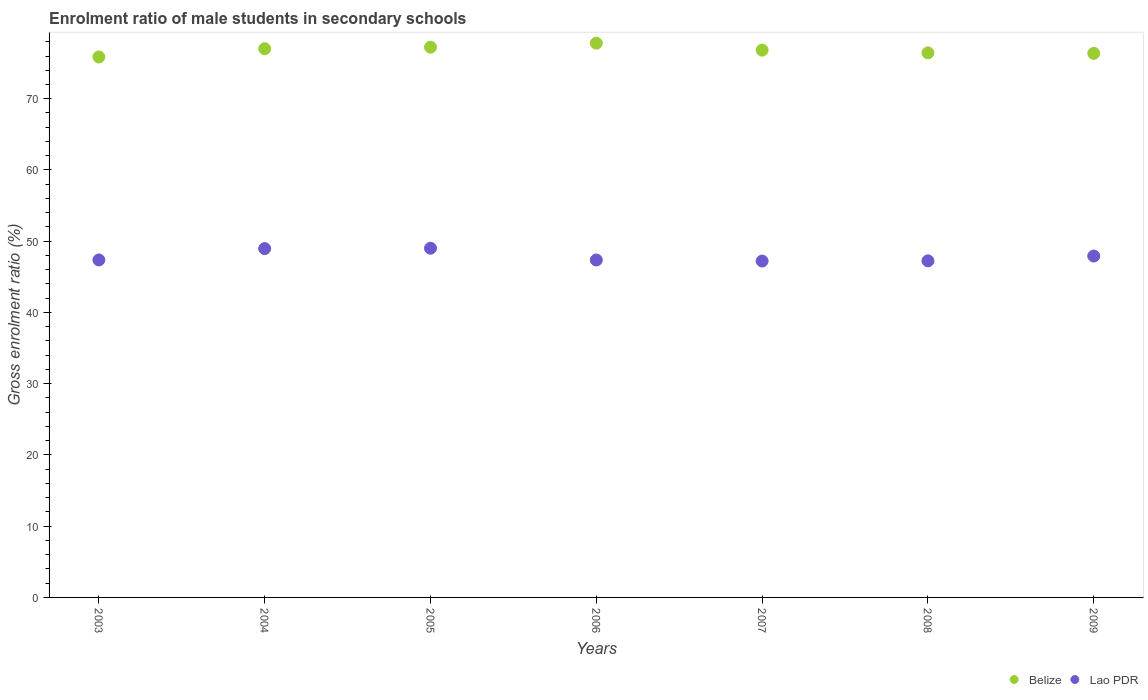Is the number of dotlines equal to the number of legend labels?
Keep it short and to the point. Yes. What is the enrolment ratio of male students in secondary schools in Belize in 2006?
Keep it short and to the point. 77.8. Across all years, what is the maximum enrolment ratio of male students in secondary schools in Lao PDR?
Make the answer very short. 49.02. Across all years, what is the minimum enrolment ratio of male students in secondary schools in Belize?
Provide a succinct answer. 75.86. What is the total enrolment ratio of male students in secondary schools in Belize in the graph?
Provide a short and direct response. 537.56. What is the difference between the enrolment ratio of male students in secondary schools in Belize in 2003 and that in 2004?
Keep it short and to the point. -1.16. What is the difference between the enrolment ratio of male students in secondary schools in Lao PDR in 2005 and the enrolment ratio of male students in secondary schools in Belize in 2007?
Offer a terse response. -27.81. What is the average enrolment ratio of male students in secondary schools in Belize per year?
Offer a terse response. 76.79. In the year 2004, what is the difference between the enrolment ratio of male students in secondary schools in Belize and enrolment ratio of male students in secondary schools in Lao PDR?
Offer a terse response. 28.05. What is the ratio of the enrolment ratio of male students in secondary schools in Lao PDR in 2004 to that in 2008?
Offer a very short reply. 1.04. Is the enrolment ratio of male students in secondary schools in Lao PDR in 2005 less than that in 2008?
Provide a short and direct response. No. What is the difference between the highest and the second highest enrolment ratio of male students in secondary schools in Lao PDR?
Keep it short and to the point. 0.05. What is the difference between the highest and the lowest enrolment ratio of male students in secondary schools in Lao PDR?
Offer a very short reply. 1.8. Is the enrolment ratio of male students in secondary schools in Belize strictly less than the enrolment ratio of male students in secondary schools in Lao PDR over the years?
Your response must be concise. No. Does the graph contain any zero values?
Your response must be concise. No. Does the graph contain grids?
Provide a succinct answer. No. How many legend labels are there?
Keep it short and to the point. 2. What is the title of the graph?
Your answer should be compact. Enrolment ratio of male students in secondary schools. Does "United Kingdom" appear as one of the legend labels in the graph?
Provide a succinct answer. No. What is the Gross enrolment ratio (%) in Belize in 2003?
Provide a short and direct response. 75.86. What is the Gross enrolment ratio (%) of Lao PDR in 2003?
Offer a terse response. 47.37. What is the Gross enrolment ratio (%) in Belize in 2004?
Provide a succinct answer. 77.02. What is the Gross enrolment ratio (%) of Lao PDR in 2004?
Make the answer very short. 48.97. What is the Gross enrolment ratio (%) of Belize in 2005?
Provide a succinct answer. 77.24. What is the Gross enrolment ratio (%) of Lao PDR in 2005?
Make the answer very short. 49.02. What is the Gross enrolment ratio (%) in Belize in 2006?
Your response must be concise. 77.8. What is the Gross enrolment ratio (%) in Lao PDR in 2006?
Keep it short and to the point. 47.37. What is the Gross enrolment ratio (%) of Belize in 2007?
Your answer should be very brief. 76.82. What is the Gross enrolment ratio (%) of Lao PDR in 2007?
Your response must be concise. 47.22. What is the Gross enrolment ratio (%) in Belize in 2008?
Offer a terse response. 76.44. What is the Gross enrolment ratio (%) of Lao PDR in 2008?
Your response must be concise. 47.24. What is the Gross enrolment ratio (%) of Belize in 2009?
Your answer should be very brief. 76.37. What is the Gross enrolment ratio (%) of Lao PDR in 2009?
Make the answer very short. 47.92. Across all years, what is the maximum Gross enrolment ratio (%) of Belize?
Your answer should be compact. 77.8. Across all years, what is the maximum Gross enrolment ratio (%) in Lao PDR?
Ensure brevity in your answer.  49.02. Across all years, what is the minimum Gross enrolment ratio (%) of Belize?
Keep it short and to the point. 75.86. Across all years, what is the minimum Gross enrolment ratio (%) of Lao PDR?
Provide a short and direct response. 47.22. What is the total Gross enrolment ratio (%) in Belize in the graph?
Provide a succinct answer. 537.56. What is the total Gross enrolment ratio (%) of Lao PDR in the graph?
Ensure brevity in your answer.  335.11. What is the difference between the Gross enrolment ratio (%) in Belize in 2003 and that in 2004?
Your answer should be very brief. -1.16. What is the difference between the Gross enrolment ratio (%) of Lao PDR in 2003 and that in 2004?
Your response must be concise. -1.59. What is the difference between the Gross enrolment ratio (%) in Belize in 2003 and that in 2005?
Provide a short and direct response. -1.38. What is the difference between the Gross enrolment ratio (%) in Lao PDR in 2003 and that in 2005?
Make the answer very short. -1.65. What is the difference between the Gross enrolment ratio (%) of Belize in 2003 and that in 2006?
Give a very brief answer. -1.94. What is the difference between the Gross enrolment ratio (%) of Lao PDR in 2003 and that in 2006?
Your answer should be very brief. 0.01. What is the difference between the Gross enrolment ratio (%) of Belize in 2003 and that in 2007?
Offer a terse response. -0.96. What is the difference between the Gross enrolment ratio (%) in Lao PDR in 2003 and that in 2007?
Offer a very short reply. 0.15. What is the difference between the Gross enrolment ratio (%) in Belize in 2003 and that in 2008?
Offer a terse response. -0.58. What is the difference between the Gross enrolment ratio (%) in Lao PDR in 2003 and that in 2008?
Provide a short and direct response. 0.13. What is the difference between the Gross enrolment ratio (%) of Belize in 2003 and that in 2009?
Ensure brevity in your answer.  -0.5. What is the difference between the Gross enrolment ratio (%) in Lao PDR in 2003 and that in 2009?
Offer a terse response. -0.55. What is the difference between the Gross enrolment ratio (%) in Belize in 2004 and that in 2005?
Provide a short and direct response. -0.22. What is the difference between the Gross enrolment ratio (%) of Lao PDR in 2004 and that in 2005?
Offer a terse response. -0.05. What is the difference between the Gross enrolment ratio (%) in Belize in 2004 and that in 2006?
Your answer should be compact. -0.78. What is the difference between the Gross enrolment ratio (%) in Lao PDR in 2004 and that in 2006?
Your response must be concise. 1.6. What is the difference between the Gross enrolment ratio (%) in Belize in 2004 and that in 2007?
Offer a terse response. 0.2. What is the difference between the Gross enrolment ratio (%) of Lao PDR in 2004 and that in 2007?
Ensure brevity in your answer.  1.75. What is the difference between the Gross enrolment ratio (%) of Belize in 2004 and that in 2008?
Offer a terse response. 0.58. What is the difference between the Gross enrolment ratio (%) of Lao PDR in 2004 and that in 2008?
Make the answer very short. 1.72. What is the difference between the Gross enrolment ratio (%) in Belize in 2004 and that in 2009?
Provide a short and direct response. 0.65. What is the difference between the Gross enrolment ratio (%) of Lao PDR in 2004 and that in 2009?
Provide a short and direct response. 1.05. What is the difference between the Gross enrolment ratio (%) of Belize in 2005 and that in 2006?
Your answer should be very brief. -0.56. What is the difference between the Gross enrolment ratio (%) in Lao PDR in 2005 and that in 2006?
Make the answer very short. 1.65. What is the difference between the Gross enrolment ratio (%) of Belize in 2005 and that in 2007?
Your answer should be very brief. 0.42. What is the difference between the Gross enrolment ratio (%) of Lao PDR in 2005 and that in 2007?
Offer a terse response. 1.8. What is the difference between the Gross enrolment ratio (%) in Belize in 2005 and that in 2008?
Give a very brief answer. 0.8. What is the difference between the Gross enrolment ratio (%) in Lao PDR in 2005 and that in 2008?
Your answer should be compact. 1.77. What is the difference between the Gross enrolment ratio (%) of Belize in 2005 and that in 2009?
Provide a succinct answer. 0.87. What is the difference between the Gross enrolment ratio (%) in Lao PDR in 2005 and that in 2009?
Offer a very short reply. 1.1. What is the difference between the Gross enrolment ratio (%) in Belize in 2006 and that in 2007?
Your answer should be compact. 0.98. What is the difference between the Gross enrolment ratio (%) in Lao PDR in 2006 and that in 2007?
Keep it short and to the point. 0.15. What is the difference between the Gross enrolment ratio (%) in Belize in 2006 and that in 2008?
Your answer should be very brief. 1.36. What is the difference between the Gross enrolment ratio (%) in Lao PDR in 2006 and that in 2008?
Make the answer very short. 0.12. What is the difference between the Gross enrolment ratio (%) in Belize in 2006 and that in 2009?
Give a very brief answer. 1.44. What is the difference between the Gross enrolment ratio (%) in Lao PDR in 2006 and that in 2009?
Give a very brief answer. -0.55. What is the difference between the Gross enrolment ratio (%) of Belize in 2007 and that in 2008?
Ensure brevity in your answer.  0.38. What is the difference between the Gross enrolment ratio (%) in Lao PDR in 2007 and that in 2008?
Offer a very short reply. -0.03. What is the difference between the Gross enrolment ratio (%) in Belize in 2007 and that in 2009?
Your response must be concise. 0.46. What is the difference between the Gross enrolment ratio (%) of Lao PDR in 2007 and that in 2009?
Ensure brevity in your answer.  -0.7. What is the difference between the Gross enrolment ratio (%) in Belize in 2008 and that in 2009?
Keep it short and to the point. 0.07. What is the difference between the Gross enrolment ratio (%) in Lao PDR in 2008 and that in 2009?
Your answer should be compact. -0.67. What is the difference between the Gross enrolment ratio (%) of Belize in 2003 and the Gross enrolment ratio (%) of Lao PDR in 2004?
Provide a short and direct response. 26.9. What is the difference between the Gross enrolment ratio (%) in Belize in 2003 and the Gross enrolment ratio (%) in Lao PDR in 2005?
Make the answer very short. 26.85. What is the difference between the Gross enrolment ratio (%) in Belize in 2003 and the Gross enrolment ratio (%) in Lao PDR in 2006?
Offer a terse response. 28.5. What is the difference between the Gross enrolment ratio (%) in Belize in 2003 and the Gross enrolment ratio (%) in Lao PDR in 2007?
Your answer should be very brief. 28.65. What is the difference between the Gross enrolment ratio (%) in Belize in 2003 and the Gross enrolment ratio (%) in Lao PDR in 2008?
Make the answer very short. 28.62. What is the difference between the Gross enrolment ratio (%) of Belize in 2003 and the Gross enrolment ratio (%) of Lao PDR in 2009?
Offer a terse response. 27.95. What is the difference between the Gross enrolment ratio (%) of Belize in 2004 and the Gross enrolment ratio (%) of Lao PDR in 2005?
Keep it short and to the point. 28. What is the difference between the Gross enrolment ratio (%) in Belize in 2004 and the Gross enrolment ratio (%) in Lao PDR in 2006?
Keep it short and to the point. 29.66. What is the difference between the Gross enrolment ratio (%) in Belize in 2004 and the Gross enrolment ratio (%) in Lao PDR in 2007?
Ensure brevity in your answer.  29.8. What is the difference between the Gross enrolment ratio (%) in Belize in 2004 and the Gross enrolment ratio (%) in Lao PDR in 2008?
Offer a very short reply. 29.78. What is the difference between the Gross enrolment ratio (%) in Belize in 2004 and the Gross enrolment ratio (%) in Lao PDR in 2009?
Offer a very short reply. 29.1. What is the difference between the Gross enrolment ratio (%) of Belize in 2005 and the Gross enrolment ratio (%) of Lao PDR in 2006?
Ensure brevity in your answer.  29.88. What is the difference between the Gross enrolment ratio (%) in Belize in 2005 and the Gross enrolment ratio (%) in Lao PDR in 2007?
Provide a short and direct response. 30.02. What is the difference between the Gross enrolment ratio (%) of Belize in 2005 and the Gross enrolment ratio (%) of Lao PDR in 2008?
Offer a very short reply. 30. What is the difference between the Gross enrolment ratio (%) in Belize in 2005 and the Gross enrolment ratio (%) in Lao PDR in 2009?
Provide a succinct answer. 29.32. What is the difference between the Gross enrolment ratio (%) of Belize in 2006 and the Gross enrolment ratio (%) of Lao PDR in 2007?
Provide a succinct answer. 30.59. What is the difference between the Gross enrolment ratio (%) of Belize in 2006 and the Gross enrolment ratio (%) of Lao PDR in 2008?
Offer a very short reply. 30.56. What is the difference between the Gross enrolment ratio (%) in Belize in 2006 and the Gross enrolment ratio (%) in Lao PDR in 2009?
Offer a terse response. 29.89. What is the difference between the Gross enrolment ratio (%) in Belize in 2007 and the Gross enrolment ratio (%) in Lao PDR in 2008?
Give a very brief answer. 29.58. What is the difference between the Gross enrolment ratio (%) of Belize in 2007 and the Gross enrolment ratio (%) of Lao PDR in 2009?
Ensure brevity in your answer.  28.9. What is the difference between the Gross enrolment ratio (%) in Belize in 2008 and the Gross enrolment ratio (%) in Lao PDR in 2009?
Make the answer very short. 28.52. What is the average Gross enrolment ratio (%) of Belize per year?
Offer a very short reply. 76.8. What is the average Gross enrolment ratio (%) in Lao PDR per year?
Your answer should be very brief. 47.87. In the year 2003, what is the difference between the Gross enrolment ratio (%) of Belize and Gross enrolment ratio (%) of Lao PDR?
Ensure brevity in your answer.  28.49. In the year 2004, what is the difference between the Gross enrolment ratio (%) of Belize and Gross enrolment ratio (%) of Lao PDR?
Give a very brief answer. 28.05. In the year 2005, what is the difference between the Gross enrolment ratio (%) in Belize and Gross enrolment ratio (%) in Lao PDR?
Give a very brief answer. 28.22. In the year 2006, what is the difference between the Gross enrolment ratio (%) in Belize and Gross enrolment ratio (%) in Lao PDR?
Keep it short and to the point. 30.44. In the year 2007, what is the difference between the Gross enrolment ratio (%) of Belize and Gross enrolment ratio (%) of Lao PDR?
Make the answer very short. 29.6. In the year 2008, what is the difference between the Gross enrolment ratio (%) of Belize and Gross enrolment ratio (%) of Lao PDR?
Make the answer very short. 29.2. In the year 2009, what is the difference between the Gross enrolment ratio (%) in Belize and Gross enrolment ratio (%) in Lao PDR?
Your answer should be very brief. 28.45. What is the ratio of the Gross enrolment ratio (%) of Belize in 2003 to that in 2004?
Provide a succinct answer. 0.98. What is the ratio of the Gross enrolment ratio (%) of Lao PDR in 2003 to that in 2004?
Ensure brevity in your answer.  0.97. What is the ratio of the Gross enrolment ratio (%) in Belize in 2003 to that in 2005?
Give a very brief answer. 0.98. What is the ratio of the Gross enrolment ratio (%) of Lao PDR in 2003 to that in 2005?
Offer a terse response. 0.97. What is the ratio of the Gross enrolment ratio (%) in Belize in 2003 to that in 2006?
Make the answer very short. 0.98. What is the ratio of the Gross enrolment ratio (%) of Lao PDR in 2003 to that in 2006?
Your answer should be compact. 1. What is the ratio of the Gross enrolment ratio (%) of Belize in 2003 to that in 2007?
Offer a very short reply. 0.99. What is the ratio of the Gross enrolment ratio (%) of Lao PDR in 2003 to that in 2007?
Keep it short and to the point. 1. What is the ratio of the Gross enrolment ratio (%) in Belize in 2003 to that in 2008?
Your answer should be very brief. 0.99. What is the ratio of the Gross enrolment ratio (%) in Lao PDR in 2003 to that in 2008?
Offer a terse response. 1. What is the ratio of the Gross enrolment ratio (%) of Lao PDR in 2003 to that in 2009?
Give a very brief answer. 0.99. What is the ratio of the Gross enrolment ratio (%) of Belize in 2004 to that in 2005?
Your answer should be compact. 1. What is the ratio of the Gross enrolment ratio (%) of Lao PDR in 2004 to that in 2005?
Provide a succinct answer. 1. What is the ratio of the Gross enrolment ratio (%) in Lao PDR in 2004 to that in 2006?
Provide a short and direct response. 1.03. What is the ratio of the Gross enrolment ratio (%) in Belize in 2004 to that in 2007?
Your response must be concise. 1. What is the ratio of the Gross enrolment ratio (%) of Lao PDR in 2004 to that in 2007?
Offer a terse response. 1.04. What is the ratio of the Gross enrolment ratio (%) of Belize in 2004 to that in 2008?
Ensure brevity in your answer.  1.01. What is the ratio of the Gross enrolment ratio (%) of Lao PDR in 2004 to that in 2008?
Ensure brevity in your answer.  1.04. What is the ratio of the Gross enrolment ratio (%) in Belize in 2004 to that in 2009?
Offer a very short reply. 1.01. What is the ratio of the Gross enrolment ratio (%) of Lao PDR in 2004 to that in 2009?
Your answer should be compact. 1.02. What is the ratio of the Gross enrolment ratio (%) of Belize in 2005 to that in 2006?
Offer a very short reply. 0.99. What is the ratio of the Gross enrolment ratio (%) of Lao PDR in 2005 to that in 2006?
Ensure brevity in your answer.  1.03. What is the ratio of the Gross enrolment ratio (%) of Belize in 2005 to that in 2007?
Provide a succinct answer. 1.01. What is the ratio of the Gross enrolment ratio (%) of Lao PDR in 2005 to that in 2007?
Offer a terse response. 1.04. What is the ratio of the Gross enrolment ratio (%) of Belize in 2005 to that in 2008?
Make the answer very short. 1.01. What is the ratio of the Gross enrolment ratio (%) in Lao PDR in 2005 to that in 2008?
Make the answer very short. 1.04. What is the ratio of the Gross enrolment ratio (%) in Belize in 2005 to that in 2009?
Your answer should be very brief. 1.01. What is the ratio of the Gross enrolment ratio (%) in Lao PDR in 2005 to that in 2009?
Your response must be concise. 1.02. What is the ratio of the Gross enrolment ratio (%) of Belize in 2006 to that in 2007?
Offer a very short reply. 1.01. What is the ratio of the Gross enrolment ratio (%) of Lao PDR in 2006 to that in 2007?
Keep it short and to the point. 1. What is the ratio of the Gross enrolment ratio (%) of Belize in 2006 to that in 2008?
Offer a very short reply. 1.02. What is the ratio of the Gross enrolment ratio (%) in Belize in 2006 to that in 2009?
Keep it short and to the point. 1.02. What is the ratio of the Gross enrolment ratio (%) of Lao PDR in 2006 to that in 2009?
Give a very brief answer. 0.99. What is the ratio of the Gross enrolment ratio (%) of Lao PDR in 2007 to that in 2009?
Offer a terse response. 0.99. What is the ratio of the Gross enrolment ratio (%) in Lao PDR in 2008 to that in 2009?
Make the answer very short. 0.99. What is the difference between the highest and the second highest Gross enrolment ratio (%) in Belize?
Provide a short and direct response. 0.56. What is the difference between the highest and the second highest Gross enrolment ratio (%) in Lao PDR?
Your answer should be compact. 0.05. What is the difference between the highest and the lowest Gross enrolment ratio (%) of Belize?
Provide a short and direct response. 1.94. What is the difference between the highest and the lowest Gross enrolment ratio (%) in Lao PDR?
Provide a short and direct response. 1.8. 